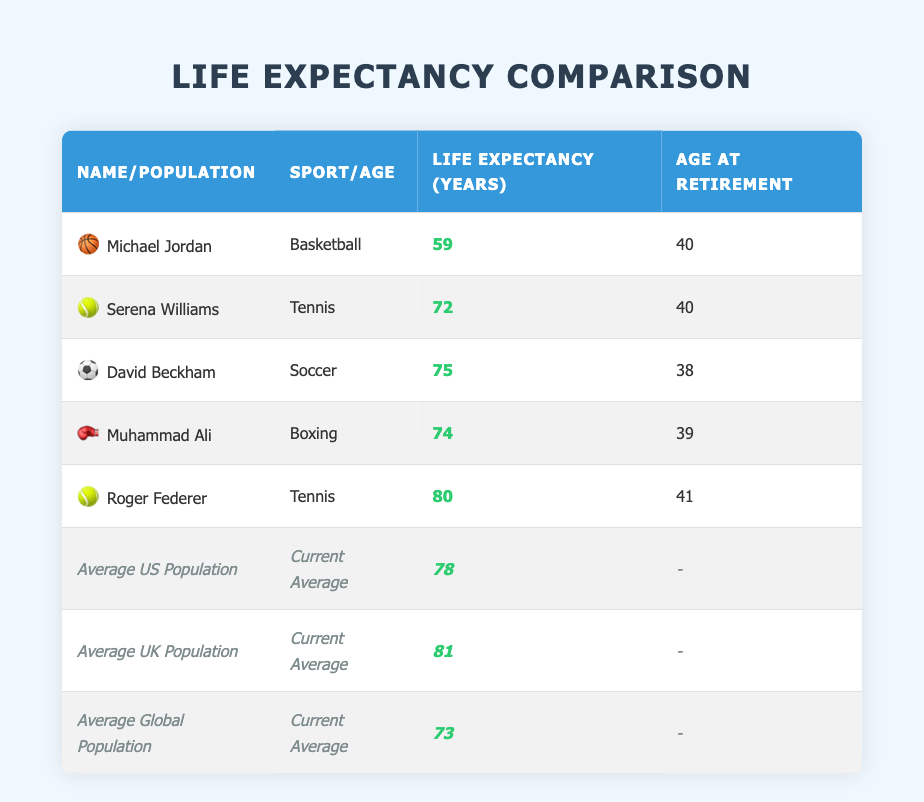What is the life expectancy of Roger Federer? According to the table, Roger Federer has a life expectancy of 80 years.
Answer: 80 Which sport personality has the lowest life expectancy? The table shows that Michael Jordan has the lowest life expectancy at 59 years.
Answer: Michael Jordan What is the average life expectancy of the general population in the UK and the US? The life expectancy for the average UK population is 81 years, and for the average US population, it is 78 years. Adding these together gives 81 + 78 = 159, and dividing by 2 gives an average of 79.5 years.
Answer: 79.5 Is Roger Federer's life expectancy greater than that of the average global population? Roger Federer's life expectancy is 80 years, while the average global population's life expectancy is 73 years. Since 80 is greater than 73, this statement is true.
Answer: Yes What is the difference in life expectancy between the average UK population and Muhammad Ali? The average UK population has a life expectancy of 81 years, and Muhammad Ali has a life expectancy of 74 years. The difference is 81 - 74 = 7 years.
Answer: 7 How many former sports personalities have a life expectancy below the average US population? The average US population has a life expectancy of 78 years. The table lists Michael Jordan (59), Serena Williams (72), Muhammad Ali (74), which totals 3.
Answer: 3 Which sport personality retired at the same age as most other sport personalities on this list? The majority of sport personalities listed, like Serena Williams and Michael Jordan, retired at the age of 40, making them the most common age at retirement in this context.
Answer: 40 What percentage of the sports personalities have a life expectancy above the average US population? Out of the five sports personalities listed, three have a life expectancy above the average US population (David Beckham, Muhammad Ali, and Roger Federer). This makes the percentage (3/5) * 100 = 60%.
Answer: 60% 